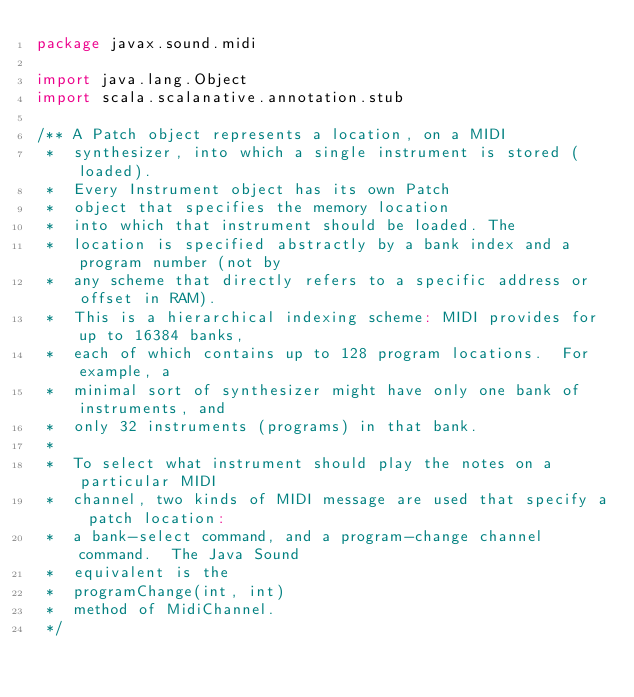Convert code to text. <code><loc_0><loc_0><loc_500><loc_500><_Scala_>package javax.sound.midi

import java.lang.Object
import scala.scalanative.annotation.stub

/** A Patch object represents a location, on a MIDI
 *  synthesizer, into which a single instrument is stored (loaded).
 *  Every Instrument object has its own Patch
 *  object that specifies the memory location
 *  into which that instrument should be loaded. The
 *  location is specified abstractly by a bank index and a program number (not by
 *  any scheme that directly refers to a specific address or offset in RAM).
 *  This is a hierarchical indexing scheme: MIDI provides for up to 16384 banks,
 *  each of which contains up to 128 program locations.  For example, a
 *  minimal sort of synthesizer might have only one bank of instruments, and
 *  only 32 instruments (programs) in that bank.
 *  
 *  To select what instrument should play the notes on a particular MIDI
 *  channel, two kinds of MIDI message are used that specify a patch location:
 *  a bank-select command, and a program-change channel command.  The Java Sound
 *  equivalent is the
 *  programChange(int, int)
 *  method of MidiChannel.
 */</code> 